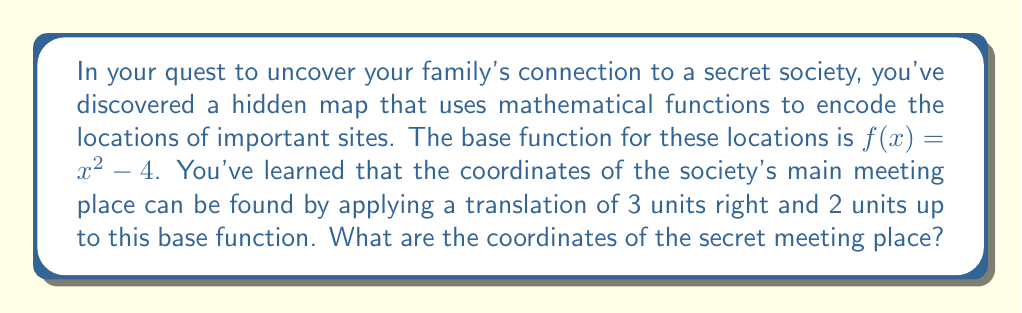Show me your answer to this math problem. To solve this problem, we need to apply the given translation to the base function $f(x) = x^2 - 4$. Let's break it down step-by-step:

1) The translation of 3 units right is represented by replacing every $x$ with $(x - 3)$. This shifts the function 3 units to the right.

2) The translation of 2 units up is represented by adding 2 to the entire function.

3) Applying these transformations to our base function:

   $g(x) = (x - 3)^2 - 4 + 2$

4) Simplify:
   $g(x) = (x - 3)^2 - 2$

5) To find the vertex of this parabola (which will be the highest point and the location of the secret meeting place), we can use the vertex form of a quadratic function: $(x - h)^2 + k$

6) Our function is already in vertex form, where $h = 3$ and $k = -2$

7) Therefore, the vertex (and the location of the secret meeting place) is at the point (3, -2)
Answer: The coordinates of the secret meeting place are (3, -2). 